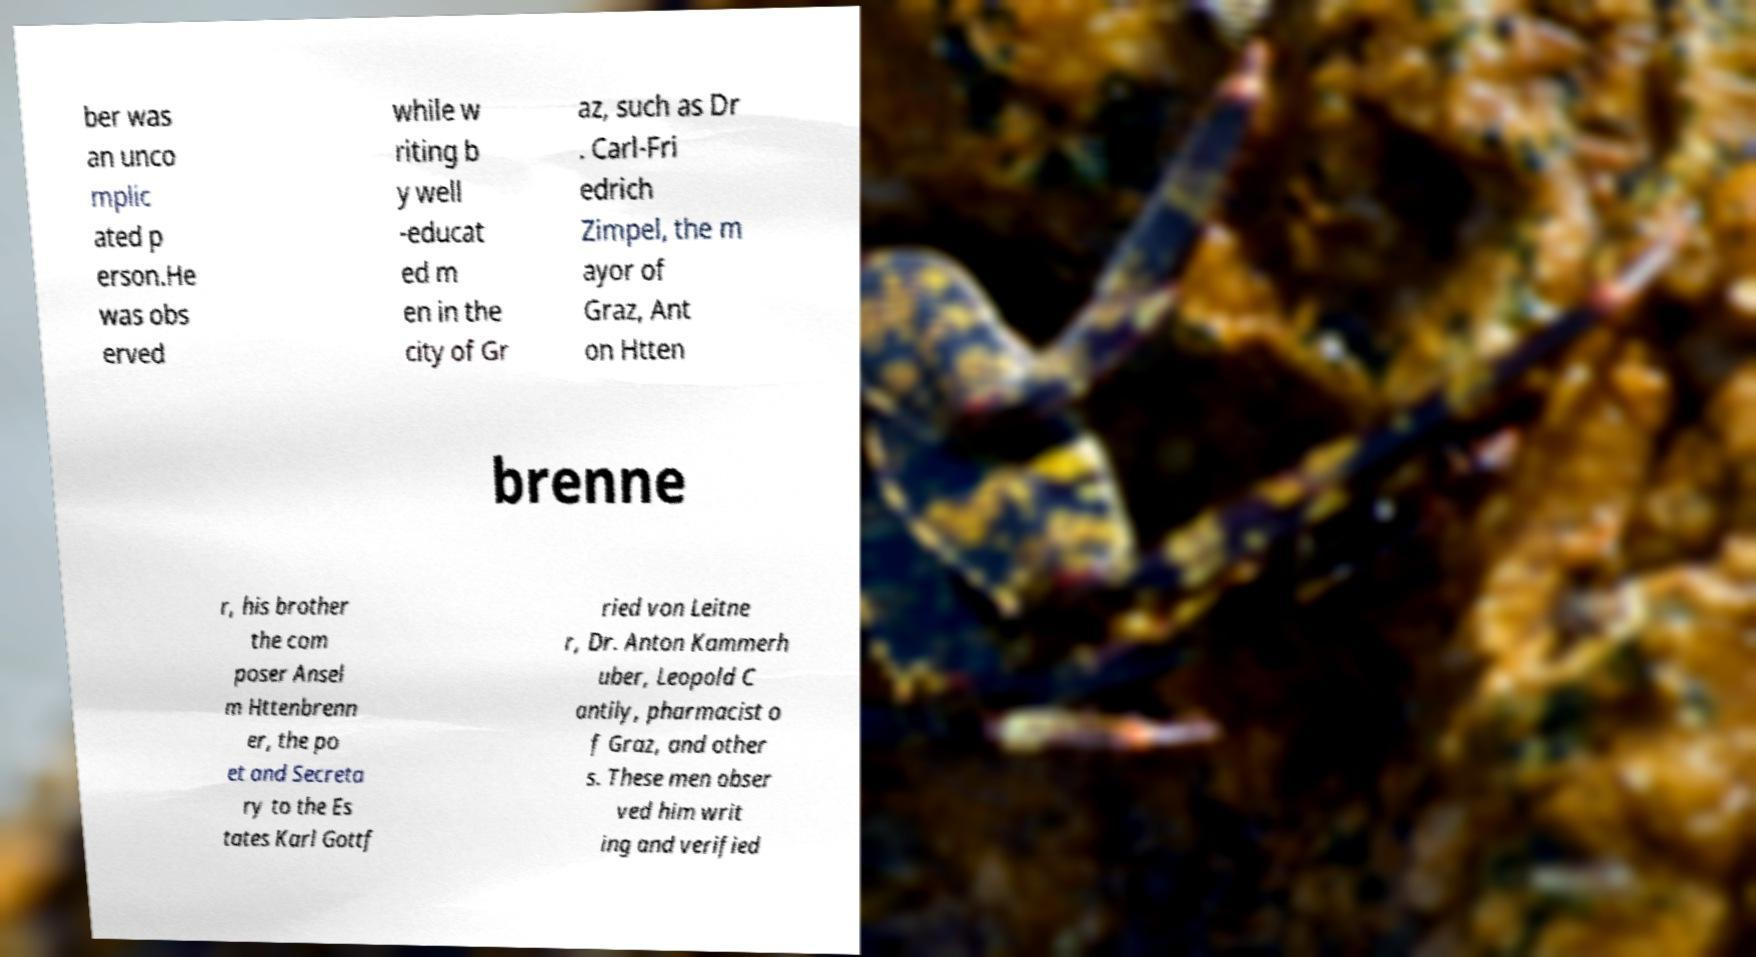Please read and relay the text visible in this image. What does it say? ber was an unco mplic ated p erson.He was obs erved while w riting b y well -educat ed m en in the city of Gr az, such as Dr . Carl-Fri edrich Zimpel, the m ayor of Graz, Ant on Htten brenne r, his brother the com poser Ansel m Httenbrenn er, the po et and Secreta ry to the Es tates Karl Gottf ried von Leitne r, Dr. Anton Kammerh uber, Leopold C antily, pharmacist o f Graz, and other s. These men obser ved him writ ing and verified 